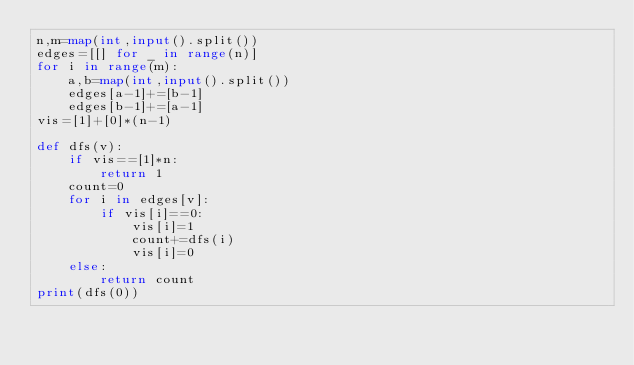<code> <loc_0><loc_0><loc_500><loc_500><_Python_>n,m=map(int,input().split())
edges=[[] for _ in range(n)]
for i in range(m):
    a,b=map(int,input().split())
    edges[a-1]+=[b-1]
    edges[b-1]+=[a-1]
vis=[1]+[0]*(n-1)

def dfs(v):
    if vis==[1]*n:
        return 1
    count=0
    for i in edges[v]:
        if vis[i]==0:
            vis[i]=1
            count+=dfs(i)
            vis[i]=0
    else:
        return count
print(dfs(0))
</code> 